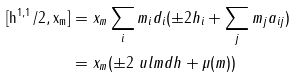<formula> <loc_0><loc_0><loc_500><loc_500>[ \tt h ^ { 1 , 1 } / 2 , x _ { m } ] & = x _ { m } \sum _ { i } m _ { i } d _ { i } ( \pm 2 h _ { i } + \sum _ { j } m _ { j } a _ { i j } ) \\ & = x _ { m } ( \pm 2 \ u l { m d h } + \mu ( m ) )</formula> 